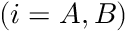<formula> <loc_0><loc_0><loc_500><loc_500>( i = A , B )</formula> 